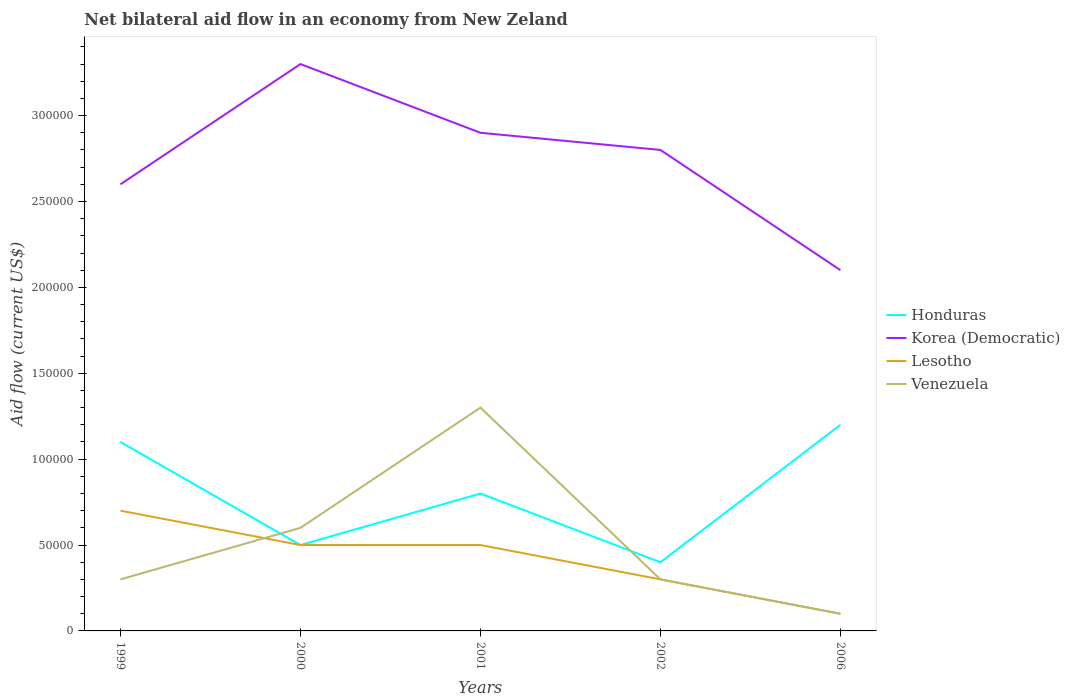Is the net bilateral aid flow in Honduras strictly greater than the net bilateral aid flow in Korea (Democratic) over the years?
Keep it short and to the point. Yes. How many lines are there?
Your response must be concise. 4. How many years are there in the graph?
Offer a very short reply. 5. What is the difference between two consecutive major ticks on the Y-axis?
Provide a succinct answer. 5.00e+04. Are the values on the major ticks of Y-axis written in scientific E-notation?
Provide a succinct answer. No. Does the graph contain any zero values?
Ensure brevity in your answer.  No. Where does the legend appear in the graph?
Keep it short and to the point. Center right. How are the legend labels stacked?
Make the answer very short. Vertical. What is the title of the graph?
Your answer should be compact. Net bilateral aid flow in an economy from New Zeland. What is the Aid flow (current US$) in Honduras in 1999?
Your response must be concise. 1.10e+05. What is the Aid flow (current US$) of Lesotho in 1999?
Your answer should be compact. 7.00e+04. What is the Aid flow (current US$) in Venezuela in 1999?
Keep it short and to the point. 3.00e+04. What is the Aid flow (current US$) of Lesotho in 2000?
Provide a succinct answer. 5.00e+04. What is the Aid flow (current US$) in Honduras in 2001?
Your answer should be compact. 8.00e+04. What is the Aid flow (current US$) of Korea (Democratic) in 2001?
Make the answer very short. 2.90e+05. What is the Aid flow (current US$) in Lesotho in 2001?
Provide a short and direct response. 5.00e+04. What is the Aid flow (current US$) in Honduras in 2002?
Your response must be concise. 4.00e+04. What is the Aid flow (current US$) of Venezuela in 2002?
Offer a very short reply. 3.00e+04. What is the Aid flow (current US$) of Honduras in 2006?
Your answer should be compact. 1.20e+05. What is the Aid flow (current US$) in Korea (Democratic) in 2006?
Keep it short and to the point. 2.10e+05. What is the Aid flow (current US$) in Lesotho in 2006?
Ensure brevity in your answer.  10000. What is the Aid flow (current US$) of Venezuela in 2006?
Your answer should be very brief. 10000. Across all years, what is the maximum Aid flow (current US$) of Korea (Democratic)?
Provide a succinct answer. 3.30e+05. Across all years, what is the minimum Aid flow (current US$) of Venezuela?
Your answer should be very brief. 10000. What is the total Aid flow (current US$) of Honduras in the graph?
Provide a succinct answer. 4.00e+05. What is the total Aid flow (current US$) in Korea (Democratic) in the graph?
Offer a terse response. 1.37e+06. What is the total Aid flow (current US$) in Lesotho in the graph?
Provide a succinct answer. 2.10e+05. What is the total Aid flow (current US$) in Venezuela in the graph?
Make the answer very short. 2.60e+05. What is the difference between the Aid flow (current US$) in Korea (Democratic) in 1999 and that in 2000?
Offer a very short reply. -7.00e+04. What is the difference between the Aid flow (current US$) in Lesotho in 1999 and that in 2000?
Your response must be concise. 2.00e+04. What is the difference between the Aid flow (current US$) of Korea (Democratic) in 1999 and that in 2002?
Your response must be concise. -2.00e+04. What is the difference between the Aid flow (current US$) in Lesotho in 1999 and that in 2002?
Make the answer very short. 4.00e+04. What is the difference between the Aid flow (current US$) of Venezuela in 1999 and that in 2002?
Provide a succinct answer. 0. What is the difference between the Aid flow (current US$) in Honduras in 1999 and that in 2006?
Your answer should be very brief. -10000. What is the difference between the Aid flow (current US$) of Venezuela in 1999 and that in 2006?
Provide a succinct answer. 2.00e+04. What is the difference between the Aid flow (current US$) of Honduras in 2000 and that in 2001?
Your response must be concise. -3.00e+04. What is the difference between the Aid flow (current US$) of Lesotho in 2000 and that in 2001?
Your answer should be very brief. 0. What is the difference between the Aid flow (current US$) in Venezuela in 2000 and that in 2001?
Provide a succinct answer. -7.00e+04. What is the difference between the Aid flow (current US$) of Honduras in 2000 and that in 2002?
Provide a short and direct response. 10000. What is the difference between the Aid flow (current US$) of Korea (Democratic) in 2000 and that in 2002?
Your answer should be compact. 5.00e+04. What is the difference between the Aid flow (current US$) in Lesotho in 2000 and that in 2002?
Your response must be concise. 2.00e+04. What is the difference between the Aid flow (current US$) in Honduras in 2000 and that in 2006?
Provide a succinct answer. -7.00e+04. What is the difference between the Aid flow (current US$) in Honduras in 2001 and that in 2002?
Offer a very short reply. 4.00e+04. What is the difference between the Aid flow (current US$) of Lesotho in 2001 and that in 2002?
Ensure brevity in your answer.  2.00e+04. What is the difference between the Aid flow (current US$) in Honduras in 2001 and that in 2006?
Your answer should be very brief. -4.00e+04. What is the difference between the Aid flow (current US$) in Venezuela in 2001 and that in 2006?
Offer a terse response. 1.20e+05. What is the difference between the Aid flow (current US$) of Korea (Democratic) in 2002 and that in 2006?
Your answer should be very brief. 7.00e+04. What is the difference between the Aid flow (current US$) of Lesotho in 2002 and that in 2006?
Your answer should be very brief. 2.00e+04. What is the difference between the Aid flow (current US$) of Venezuela in 2002 and that in 2006?
Ensure brevity in your answer.  2.00e+04. What is the difference between the Aid flow (current US$) of Honduras in 1999 and the Aid flow (current US$) of Korea (Democratic) in 2000?
Your response must be concise. -2.20e+05. What is the difference between the Aid flow (current US$) of Honduras in 1999 and the Aid flow (current US$) of Lesotho in 2000?
Ensure brevity in your answer.  6.00e+04. What is the difference between the Aid flow (current US$) in Lesotho in 1999 and the Aid flow (current US$) in Venezuela in 2000?
Your response must be concise. 10000. What is the difference between the Aid flow (current US$) in Honduras in 1999 and the Aid flow (current US$) in Lesotho in 2001?
Make the answer very short. 6.00e+04. What is the difference between the Aid flow (current US$) in Korea (Democratic) in 1999 and the Aid flow (current US$) in Lesotho in 2001?
Provide a succinct answer. 2.10e+05. What is the difference between the Aid flow (current US$) in Lesotho in 1999 and the Aid flow (current US$) in Venezuela in 2001?
Give a very brief answer. -6.00e+04. What is the difference between the Aid flow (current US$) of Honduras in 1999 and the Aid flow (current US$) of Lesotho in 2002?
Provide a succinct answer. 8.00e+04. What is the difference between the Aid flow (current US$) of Honduras in 1999 and the Aid flow (current US$) of Venezuela in 2002?
Ensure brevity in your answer.  8.00e+04. What is the difference between the Aid flow (current US$) in Korea (Democratic) in 1999 and the Aid flow (current US$) in Venezuela in 2002?
Your answer should be compact. 2.30e+05. What is the difference between the Aid flow (current US$) in Lesotho in 1999 and the Aid flow (current US$) in Venezuela in 2002?
Your answer should be compact. 4.00e+04. What is the difference between the Aid flow (current US$) in Honduras in 1999 and the Aid flow (current US$) in Venezuela in 2006?
Keep it short and to the point. 1.00e+05. What is the difference between the Aid flow (current US$) of Korea (Democratic) in 1999 and the Aid flow (current US$) of Lesotho in 2006?
Give a very brief answer. 2.50e+05. What is the difference between the Aid flow (current US$) of Korea (Democratic) in 1999 and the Aid flow (current US$) of Venezuela in 2006?
Keep it short and to the point. 2.50e+05. What is the difference between the Aid flow (current US$) in Lesotho in 1999 and the Aid flow (current US$) in Venezuela in 2006?
Ensure brevity in your answer.  6.00e+04. What is the difference between the Aid flow (current US$) of Honduras in 2000 and the Aid flow (current US$) of Korea (Democratic) in 2001?
Your answer should be compact. -2.40e+05. What is the difference between the Aid flow (current US$) of Korea (Democratic) in 2000 and the Aid flow (current US$) of Venezuela in 2001?
Your answer should be very brief. 2.00e+05. What is the difference between the Aid flow (current US$) in Lesotho in 2000 and the Aid flow (current US$) in Venezuela in 2001?
Give a very brief answer. -8.00e+04. What is the difference between the Aid flow (current US$) in Honduras in 2000 and the Aid flow (current US$) in Korea (Democratic) in 2002?
Give a very brief answer. -2.30e+05. What is the difference between the Aid flow (current US$) of Korea (Democratic) in 2000 and the Aid flow (current US$) of Venezuela in 2002?
Offer a terse response. 3.00e+05. What is the difference between the Aid flow (current US$) in Lesotho in 2000 and the Aid flow (current US$) in Venezuela in 2002?
Your answer should be compact. 2.00e+04. What is the difference between the Aid flow (current US$) of Honduras in 2000 and the Aid flow (current US$) of Korea (Democratic) in 2006?
Keep it short and to the point. -1.60e+05. What is the difference between the Aid flow (current US$) in Korea (Democratic) in 2000 and the Aid flow (current US$) in Lesotho in 2006?
Offer a terse response. 3.20e+05. What is the difference between the Aid flow (current US$) of Korea (Democratic) in 2000 and the Aid flow (current US$) of Venezuela in 2006?
Keep it short and to the point. 3.20e+05. What is the difference between the Aid flow (current US$) in Lesotho in 2000 and the Aid flow (current US$) in Venezuela in 2006?
Offer a very short reply. 4.00e+04. What is the difference between the Aid flow (current US$) in Honduras in 2001 and the Aid flow (current US$) in Korea (Democratic) in 2002?
Provide a succinct answer. -2.00e+05. What is the difference between the Aid flow (current US$) of Honduras in 2001 and the Aid flow (current US$) of Lesotho in 2002?
Make the answer very short. 5.00e+04. What is the difference between the Aid flow (current US$) in Korea (Democratic) in 2001 and the Aid flow (current US$) in Venezuela in 2002?
Offer a very short reply. 2.60e+05. What is the difference between the Aid flow (current US$) of Lesotho in 2001 and the Aid flow (current US$) of Venezuela in 2002?
Your answer should be very brief. 2.00e+04. What is the difference between the Aid flow (current US$) in Honduras in 2001 and the Aid flow (current US$) in Lesotho in 2006?
Provide a short and direct response. 7.00e+04. What is the difference between the Aid flow (current US$) of Honduras in 2001 and the Aid flow (current US$) of Venezuela in 2006?
Give a very brief answer. 7.00e+04. What is the difference between the Aid flow (current US$) in Korea (Democratic) in 2001 and the Aid flow (current US$) in Lesotho in 2006?
Keep it short and to the point. 2.80e+05. What is the difference between the Aid flow (current US$) of Korea (Democratic) in 2001 and the Aid flow (current US$) of Venezuela in 2006?
Keep it short and to the point. 2.80e+05. What is the average Aid flow (current US$) of Honduras per year?
Provide a succinct answer. 8.00e+04. What is the average Aid flow (current US$) in Korea (Democratic) per year?
Ensure brevity in your answer.  2.74e+05. What is the average Aid flow (current US$) of Lesotho per year?
Offer a very short reply. 4.20e+04. What is the average Aid flow (current US$) of Venezuela per year?
Your answer should be compact. 5.20e+04. In the year 1999, what is the difference between the Aid flow (current US$) in Honduras and Aid flow (current US$) in Lesotho?
Make the answer very short. 4.00e+04. In the year 1999, what is the difference between the Aid flow (current US$) in Honduras and Aid flow (current US$) in Venezuela?
Ensure brevity in your answer.  8.00e+04. In the year 1999, what is the difference between the Aid flow (current US$) in Korea (Democratic) and Aid flow (current US$) in Venezuela?
Your response must be concise. 2.30e+05. In the year 1999, what is the difference between the Aid flow (current US$) in Lesotho and Aid flow (current US$) in Venezuela?
Your response must be concise. 4.00e+04. In the year 2000, what is the difference between the Aid flow (current US$) of Honduras and Aid flow (current US$) of Korea (Democratic)?
Your answer should be compact. -2.80e+05. In the year 2000, what is the difference between the Aid flow (current US$) of Korea (Democratic) and Aid flow (current US$) of Lesotho?
Offer a terse response. 2.80e+05. In the year 2001, what is the difference between the Aid flow (current US$) of Honduras and Aid flow (current US$) of Venezuela?
Your answer should be compact. -5.00e+04. In the year 2001, what is the difference between the Aid flow (current US$) in Lesotho and Aid flow (current US$) in Venezuela?
Make the answer very short. -8.00e+04. In the year 2002, what is the difference between the Aid flow (current US$) of Honduras and Aid flow (current US$) of Korea (Democratic)?
Your response must be concise. -2.40e+05. In the year 2002, what is the difference between the Aid flow (current US$) in Honduras and Aid flow (current US$) in Lesotho?
Ensure brevity in your answer.  10000. In the year 2002, what is the difference between the Aid flow (current US$) in Korea (Democratic) and Aid flow (current US$) in Venezuela?
Offer a terse response. 2.50e+05. In the year 2002, what is the difference between the Aid flow (current US$) of Lesotho and Aid flow (current US$) of Venezuela?
Give a very brief answer. 0. In the year 2006, what is the difference between the Aid flow (current US$) of Honduras and Aid flow (current US$) of Korea (Democratic)?
Ensure brevity in your answer.  -9.00e+04. In the year 2006, what is the difference between the Aid flow (current US$) of Honduras and Aid flow (current US$) of Venezuela?
Keep it short and to the point. 1.10e+05. In the year 2006, what is the difference between the Aid flow (current US$) of Korea (Democratic) and Aid flow (current US$) of Venezuela?
Make the answer very short. 2.00e+05. What is the ratio of the Aid flow (current US$) of Honduras in 1999 to that in 2000?
Your answer should be compact. 2.2. What is the ratio of the Aid flow (current US$) in Korea (Democratic) in 1999 to that in 2000?
Provide a short and direct response. 0.79. What is the ratio of the Aid flow (current US$) of Lesotho in 1999 to that in 2000?
Keep it short and to the point. 1.4. What is the ratio of the Aid flow (current US$) of Honduras in 1999 to that in 2001?
Provide a succinct answer. 1.38. What is the ratio of the Aid flow (current US$) in Korea (Democratic) in 1999 to that in 2001?
Make the answer very short. 0.9. What is the ratio of the Aid flow (current US$) of Venezuela in 1999 to that in 2001?
Your answer should be compact. 0.23. What is the ratio of the Aid flow (current US$) in Honduras in 1999 to that in 2002?
Provide a short and direct response. 2.75. What is the ratio of the Aid flow (current US$) of Lesotho in 1999 to that in 2002?
Provide a short and direct response. 2.33. What is the ratio of the Aid flow (current US$) in Venezuela in 1999 to that in 2002?
Give a very brief answer. 1. What is the ratio of the Aid flow (current US$) of Honduras in 1999 to that in 2006?
Ensure brevity in your answer.  0.92. What is the ratio of the Aid flow (current US$) of Korea (Democratic) in 1999 to that in 2006?
Give a very brief answer. 1.24. What is the ratio of the Aid flow (current US$) of Venezuela in 1999 to that in 2006?
Offer a very short reply. 3. What is the ratio of the Aid flow (current US$) in Korea (Democratic) in 2000 to that in 2001?
Offer a terse response. 1.14. What is the ratio of the Aid flow (current US$) in Lesotho in 2000 to that in 2001?
Give a very brief answer. 1. What is the ratio of the Aid flow (current US$) in Venezuela in 2000 to that in 2001?
Give a very brief answer. 0.46. What is the ratio of the Aid flow (current US$) in Korea (Democratic) in 2000 to that in 2002?
Give a very brief answer. 1.18. What is the ratio of the Aid flow (current US$) of Honduras in 2000 to that in 2006?
Offer a terse response. 0.42. What is the ratio of the Aid flow (current US$) in Korea (Democratic) in 2000 to that in 2006?
Offer a terse response. 1.57. What is the ratio of the Aid flow (current US$) of Venezuela in 2000 to that in 2006?
Keep it short and to the point. 6. What is the ratio of the Aid flow (current US$) of Honduras in 2001 to that in 2002?
Provide a succinct answer. 2. What is the ratio of the Aid flow (current US$) of Korea (Democratic) in 2001 to that in 2002?
Your answer should be compact. 1.04. What is the ratio of the Aid flow (current US$) of Lesotho in 2001 to that in 2002?
Make the answer very short. 1.67. What is the ratio of the Aid flow (current US$) of Venezuela in 2001 to that in 2002?
Make the answer very short. 4.33. What is the ratio of the Aid flow (current US$) of Honduras in 2001 to that in 2006?
Your answer should be very brief. 0.67. What is the ratio of the Aid flow (current US$) in Korea (Democratic) in 2001 to that in 2006?
Your response must be concise. 1.38. What is the ratio of the Aid flow (current US$) of Honduras in 2002 to that in 2006?
Your answer should be compact. 0.33. What is the ratio of the Aid flow (current US$) of Korea (Democratic) in 2002 to that in 2006?
Provide a succinct answer. 1.33. What is the ratio of the Aid flow (current US$) in Lesotho in 2002 to that in 2006?
Offer a terse response. 3. What is the difference between the highest and the second highest Aid flow (current US$) of Honduras?
Keep it short and to the point. 10000. What is the difference between the highest and the second highest Aid flow (current US$) of Lesotho?
Make the answer very short. 2.00e+04. What is the difference between the highest and the lowest Aid flow (current US$) in Honduras?
Provide a short and direct response. 8.00e+04. What is the difference between the highest and the lowest Aid flow (current US$) of Korea (Democratic)?
Your answer should be compact. 1.20e+05. What is the difference between the highest and the lowest Aid flow (current US$) in Lesotho?
Make the answer very short. 6.00e+04. 